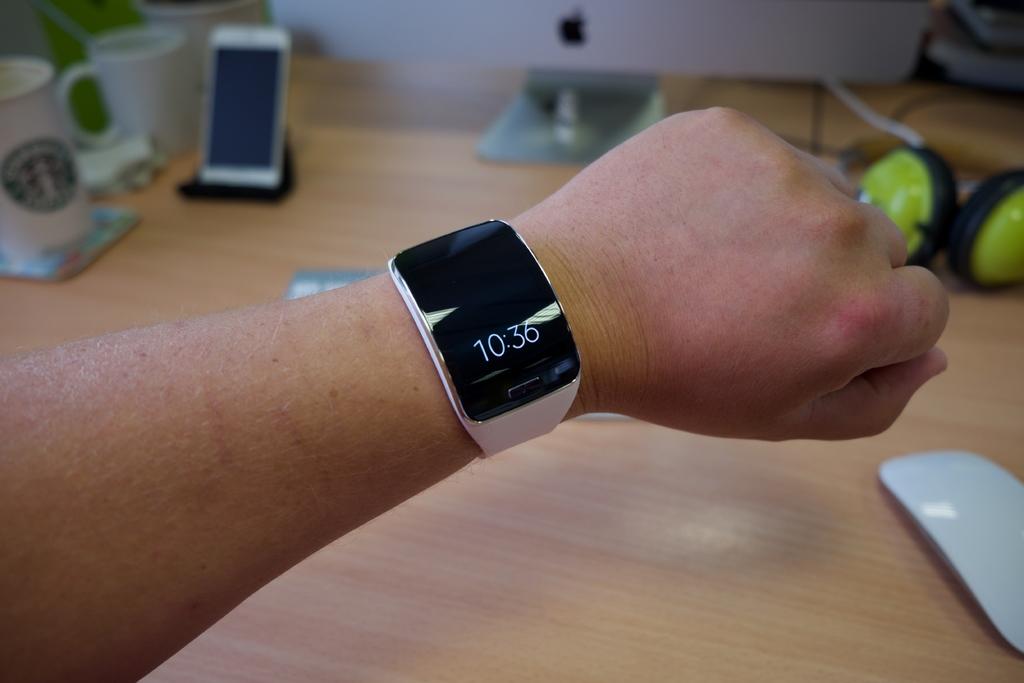What time does the watch say?
Provide a succinct answer. 10:36. How many cups are in the background?
Offer a very short reply. Answering does not require reading text in the image. 